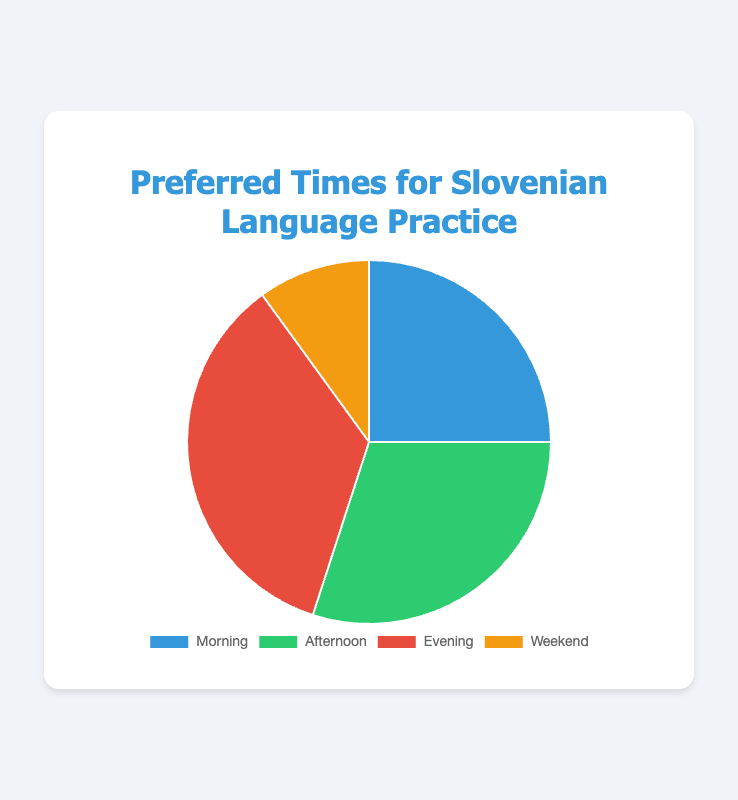What's the most preferred time for Slovenian language practice based on the pie chart? The pie chart shows different percentages for each time period. The "Evening" segment has the highest percentage, which is 35%.
Answer: Evening Which time period is preferred the least for Slovenian language practice? By examining the pie chart, the "Weekend" segment has the smallest percentage, which is 10%.
Answer: Weekend How much more popular is the Evening time for practice compared to the Weekend? The percentage for the Evening is 35% and for the Weekend is 10%. The difference is 35% - 10% = 25%.
Answer: 25% If we combine the Morning and Afternoon preferences, what percentage of people prefer practicing during these times? The Morning and Afternoon percentages are 25% and 30% respectively. Adding them gives 25% + 30% = 55%.
Answer: 55% What is the average percentage for all the time periods shown on the chart? To find the average, add all the percentages and divide by the number of time periods: (25% + 30% + 35% + 10%) / 4 = 100% / 4 = 25%.
Answer: 25% Which segments are visually adjacent and together make up more than 50% of preferences for Slovenian language practice? The "Morning" and "Afternoon" segments are adjacent and together they make up 25% + 30% = 55%.
Answer: Morning and Afternoon How does the percentage preference for the Afternoon compare to the Morning? The Afternoon preference (30%) is 5% higher than the Morning preference (25%).
Answer: Afternoon is 5% higher What's the percentage difference between the two most and two least preferred time periods? The two most preferred are Evening (35%) and Afternoon (30%), and the two least preferred are Morning (25%) and Weekend (10%). The difference is (35% + 30%) - (25% + 10%) = 65% - 35% = 30%.
Answer: 30% What color represents the least preferred time period for practice? The "Weekend" segment has the smallest percentage and is represented by the color yellow on the pie chart.
Answer: Yellow 